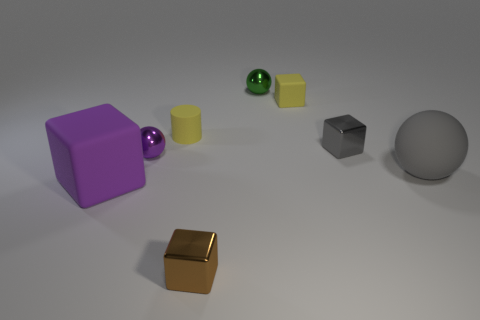How many objects are either tiny metallic balls behind the gray metallic block or gray metallic cubes?
Provide a succinct answer. 2. Are there any things right of the tiny metallic sphere to the left of the small ball that is on the right side of the purple metal sphere?
Offer a very short reply. Yes. What number of tiny red objects are there?
Provide a succinct answer. 0. What number of objects are either tiny metallic cubes that are in front of the large gray thing or balls that are left of the tiny yellow cylinder?
Your response must be concise. 2. Do the metallic block to the left of the gray block and the tiny gray cube have the same size?
Keep it short and to the point. Yes. There is a rubber thing that is the same shape as the tiny green shiny thing; what is its size?
Keep it short and to the point. Large. There is a yellow cylinder that is the same size as the gray cube; what is its material?
Ensure brevity in your answer.  Rubber. What material is the big gray object that is the same shape as the green object?
Your answer should be compact. Rubber. How many other objects are the same size as the green thing?
Keep it short and to the point. 5. What number of small objects have the same color as the cylinder?
Ensure brevity in your answer.  1. 